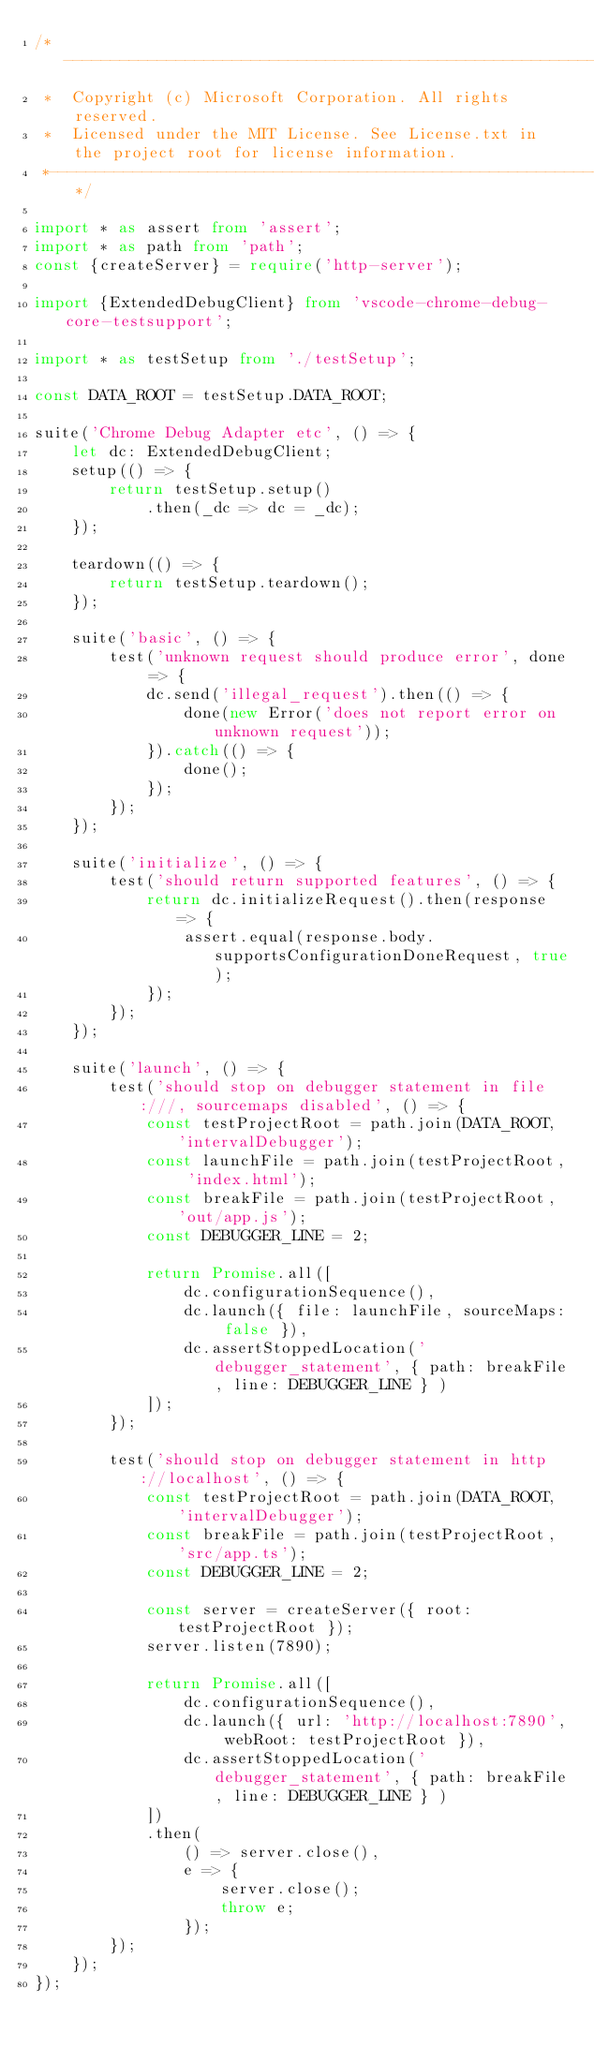Convert code to text. <code><loc_0><loc_0><loc_500><loc_500><_TypeScript_>/*---------------------------------------------------------------------------------------------
 *  Copyright (c) Microsoft Corporation. All rights reserved.
 *  Licensed under the MIT License. See License.txt in the project root for license information.
 *--------------------------------------------------------------------------------------------*/

import * as assert from 'assert';
import * as path from 'path';
const {createServer} = require('http-server');

import {ExtendedDebugClient} from 'vscode-chrome-debug-core-testsupport';

import * as testSetup from './testSetup';

const DATA_ROOT = testSetup.DATA_ROOT;

suite('Chrome Debug Adapter etc', () => {
    let dc: ExtendedDebugClient;
    setup(() => {
        return testSetup.setup()
            .then(_dc => dc = _dc);
    });

    teardown(() => {
        return testSetup.teardown();
    });

    suite('basic', () => {
        test('unknown request should produce error', done => {
            dc.send('illegal_request').then(() => {
                done(new Error('does not report error on unknown request'));
            }).catch(() => {
                done();
            });
        });
    });

    suite('initialize', () => {
        test('should return supported features', () => {
            return dc.initializeRequest().then(response => {
                assert.equal(response.body.supportsConfigurationDoneRequest, true);
            });
        });
    });

    suite('launch', () => {
        test('should stop on debugger statement in file:///, sourcemaps disabled', () => {
            const testProjectRoot = path.join(DATA_ROOT, 'intervalDebugger');
            const launchFile = path.join(testProjectRoot, 'index.html');
            const breakFile = path.join(testProjectRoot, 'out/app.js');
            const DEBUGGER_LINE = 2;

            return Promise.all([
                dc.configurationSequence(),
                dc.launch({ file: launchFile, sourceMaps: false }),
                dc.assertStoppedLocation('debugger_statement', { path: breakFile, line: DEBUGGER_LINE } )
            ]);
        });

        test('should stop on debugger statement in http://localhost', () => {
            const testProjectRoot = path.join(DATA_ROOT, 'intervalDebugger');
            const breakFile = path.join(testProjectRoot, 'src/app.ts');
            const DEBUGGER_LINE = 2;

            const server = createServer({ root: testProjectRoot });
            server.listen(7890);

            return Promise.all([
                dc.configurationSequence(),
                dc.launch({ url: 'http://localhost:7890', webRoot: testProjectRoot }),
                dc.assertStoppedLocation('debugger_statement', { path: breakFile, line: DEBUGGER_LINE } )
            ])
            .then(
                () => server.close(),
                e => {
                    server.close();
                    throw e;
                });
        });
    });
});</code> 